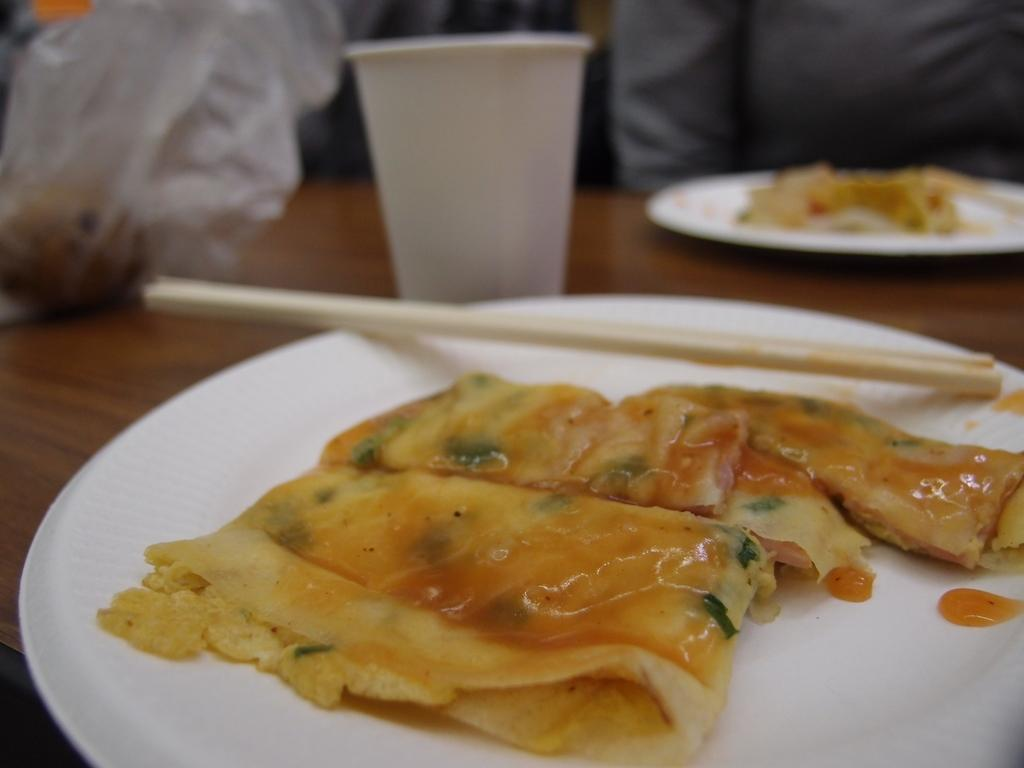What is on the white plate in the image? There is food on a white plate in the image. What else can be seen on the table besides the plate? There is a glass in the image. Can you describe the person in the background of the image? Unfortunately, the facts provided do not give enough information to describe the person in the background. What type of mark can be seen on the desk in the image? There is no desk present in the image, so it is not possible to answer that question. 